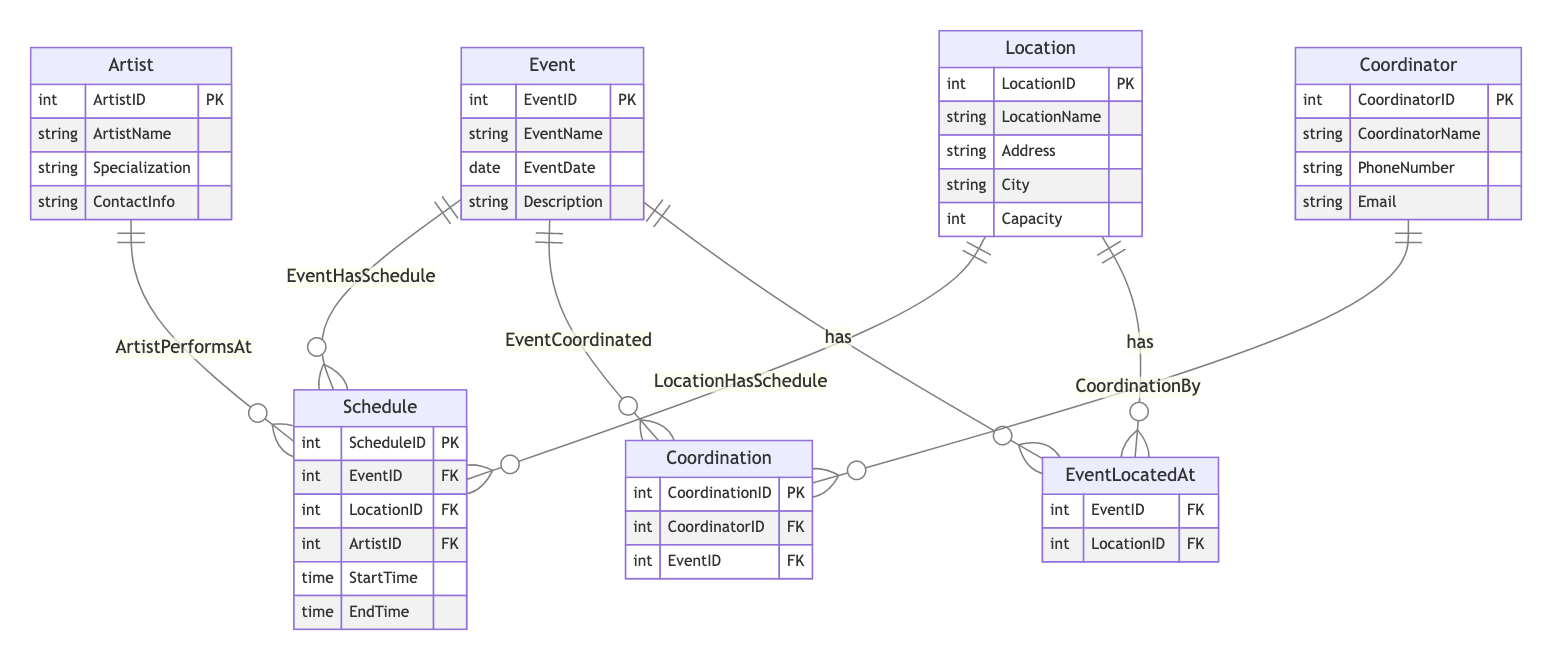What is the primary key of the Event entity? The primary key of the Event entity is explicitly stated in the diagram as EventID. This unique identifier allows each event to be distinguished from others.
Answer: EventID How many attributes does the Location entity have? By examining the Location entity in the diagram, we can count its attributes: LocationID, LocationName, Address, City, and Capacity. This gives us a total of five attributes.
Answer: 5 Which entity is related to the Schedule by the relationship "ArtistPerformsAt"? In the diagram, the relationship "ArtistPerformsAt" is shown connecting the Artist entity to the Schedule entity. This indicates that artists perform at scheduled events.
Answer: Artist How many foreign keys are there in the Schedule entity? The Schedule entity includes three foreign keys, which are EventID, LocationID, and ArtistID. Each of these connects to their respective primary entities, indicating which event, location, and artist are associated with the schedule.
Answer: 3 What is the relationship between Event and Location? The relationship is defined by "EventLocatedAt", which connects the Event entity to the Location entity. This signifies that each event is located at a specific venue.
Answer: EventLocatedAt Which entity has a direct relationship with Coordination? The Coordination entity has a direct relationship with the Event entity as indicated by the "EventCoordinated" relationship. This shows that coordinators oversee events through this coordination process.
Answer: Event What type of relationship is "LocationHasSchedule"? The "LocationHasSchedule" relationship represents a one-to-many relationship, where each location can have multiple schedules assigned to it. This reflects that various events can occur at the same location but at different times.
Answer: One-to-many How many entities are coordinated by a single Coordinator? The diagram does not specify an upper limit for how many entities a Coordinator can coordinate, but it implies through the relationships that a single Coordinator can manage multiple events, indicating a possibly many-to-many relationship.
Answer: Many What does the Coordinator entity represent in the diagram? The Coordinator entity represents individuals responsible for planning and overseeing the events' execution, with their details captured through attributes like CoordinatorName and ContactInfo.
Answer: Individuals 